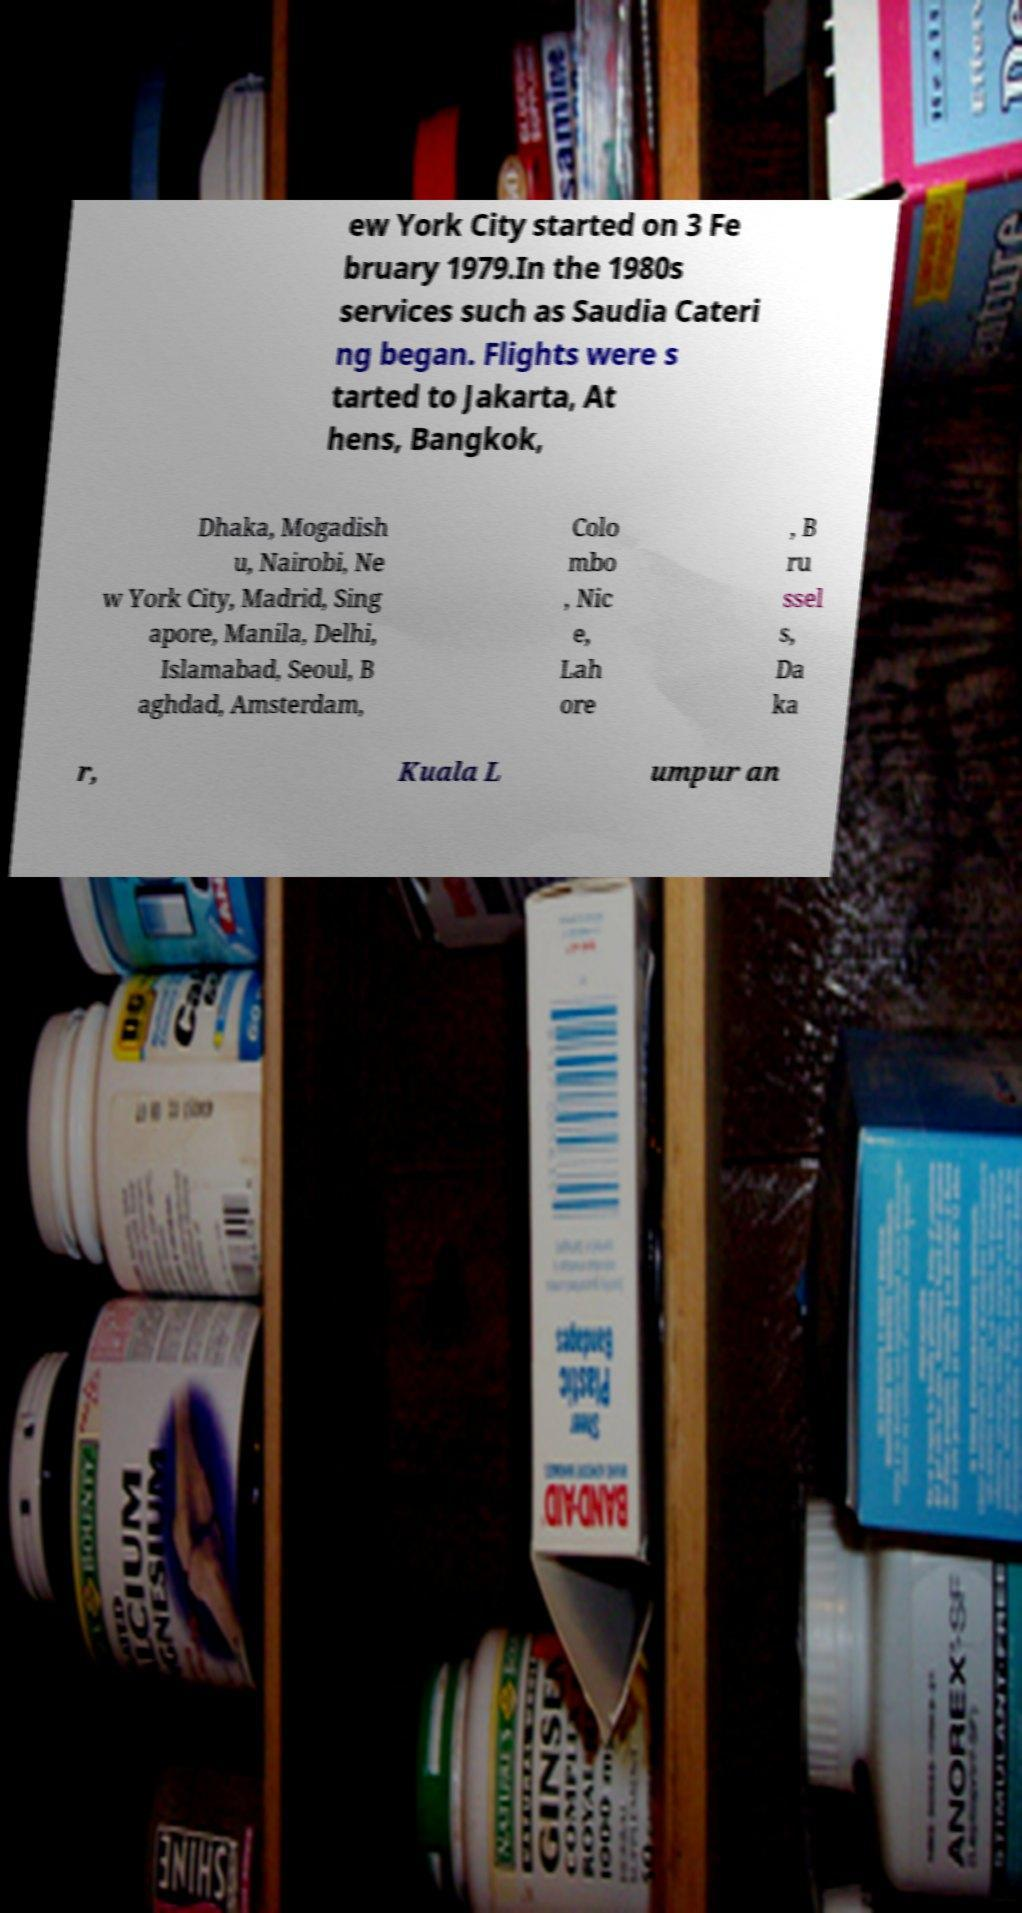For documentation purposes, I need the text within this image transcribed. Could you provide that? ew York City started on 3 Fe bruary 1979.In the 1980s services such as Saudia Cateri ng began. Flights were s tarted to Jakarta, At hens, Bangkok, Dhaka, Mogadish u, Nairobi, Ne w York City, Madrid, Sing apore, Manila, Delhi, Islamabad, Seoul, B aghdad, Amsterdam, Colo mbo , Nic e, Lah ore , B ru ssel s, Da ka r, Kuala L umpur an 